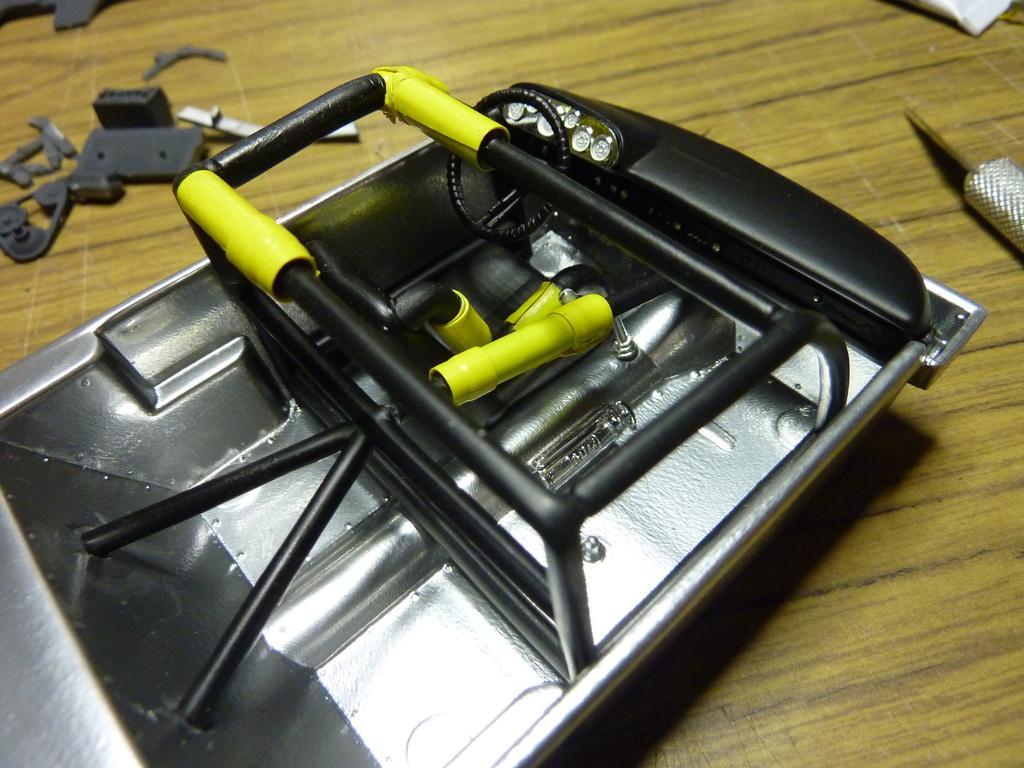Describe this image in one or two sentences. In this image there is a toy vehicle on the wooden plank. There are few nuts and parts of vehicles are on the wooden plank. Right top there is a tube. 